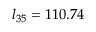<formula> <loc_0><loc_0><loc_500><loc_500>l _ { 3 5 } = 1 1 0 . 7 4</formula> 